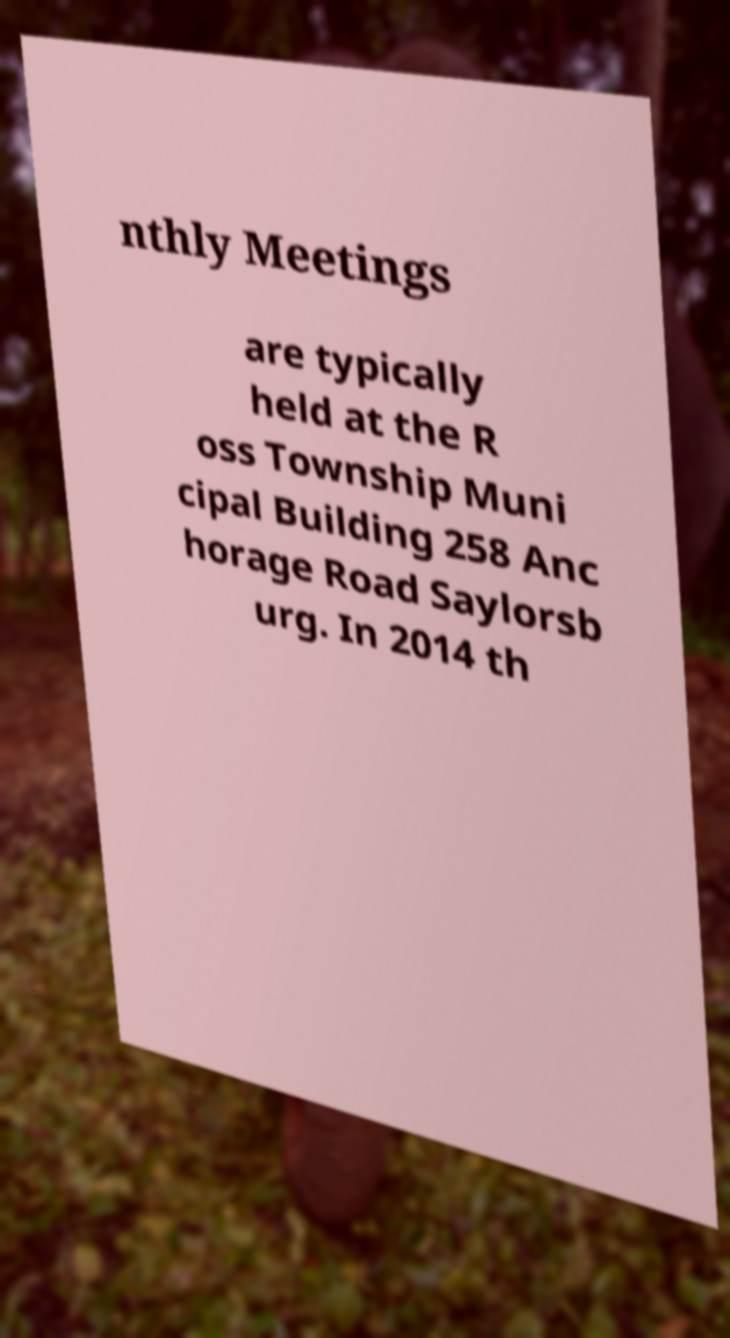What messages or text are displayed in this image? I need them in a readable, typed format. nthly Meetings are typically held at the R oss Township Muni cipal Building 258 Anc horage Road Saylorsb urg. In 2014 th 